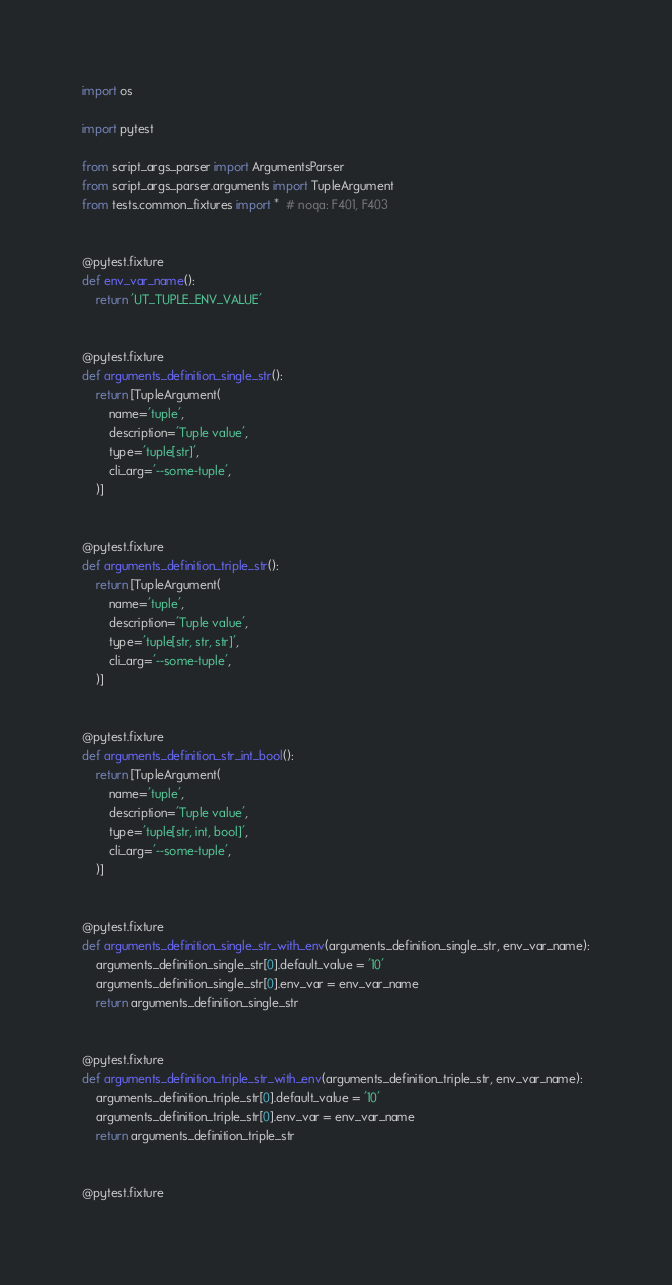Convert code to text. <code><loc_0><loc_0><loc_500><loc_500><_Python_>import os

import pytest

from script_args_parser import ArgumentsParser
from script_args_parser.arguments import TupleArgument
from tests.common_fixtures import *  # noqa: F401, F403


@pytest.fixture
def env_var_name():
    return 'UT_TUPLE_ENV_VALUE'


@pytest.fixture
def arguments_definition_single_str():
    return [TupleArgument(
        name='tuple',
        description='Tuple value',
        type='tuple[str]',
        cli_arg='--some-tuple',
    )]


@pytest.fixture
def arguments_definition_triple_str():
    return [TupleArgument(
        name='tuple',
        description='Tuple value',
        type='tuple[str, str, str]',
        cli_arg='--some-tuple',
    )]


@pytest.fixture
def arguments_definition_str_int_bool():
    return [TupleArgument(
        name='tuple',
        description='Tuple value',
        type='tuple[str, int, bool]',
        cli_arg='--some-tuple',
    )]


@pytest.fixture
def arguments_definition_single_str_with_env(arguments_definition_single_str, env_var_name):
    arguments_definition_single_str[0].default_value = '10'
    arguments_definition_single_str[0].env_var = env_var_name
    return arguments_definition_single_str


@pytest.fixture
def arguments_definition_triple_str_with_env(arguments_definition_triple_str, env_var_name):
    arguments_definition_triple_str[0].default_value = '10'
    arguments_definition_triple_str[0].env_var = env_var_name
    return arguments_definition_triple_str


@pytest.fixture</code> 